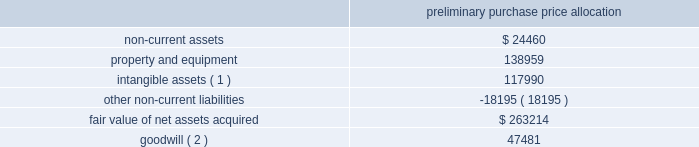American tower corporation and subsidiaries notes to consolidated financial statements the table summarizes the preliminary allocation of the aggregate purchase consideration paid and the amounts of assets acquired and liabilities assumed based upon their estimated fair value at the date of acquisition ( in thousands ) : preliminary purchase price allocation .
( 1 ) consists of customer-related intangibles of approximately $ 80.0 million and network location intangibles of approximately $ 38.0 million .
The customer-related intangibles and network location intangibles are being amortized on a straight-line basis over periods of up to 20 years .
( 2 ) the company expects that the goodwill recorded will be deductible for tax purposes .
The goodwill was allocated to the company 2019s international rental and management segment .
Ghana acquisition 2014on december 6 , 2010 , the company entered into a definitive agreement with mtn group limited ( 201cmtn group 201d ) to establish a joint venture in ghana .
The joint venture is controlled by a holding company of which a wholly owned subsidiary of the company ( the 201catc ghana subsidiary 201d ) holds a 51% ( 51 % ) interest and mobile telephone networks ( netherlands ) b.v. , a wholly owned subsidiary of mtn group ( the 201cmtn ghana subsidiary 201d ) holds a 49% ( 49 % ) interest .
The joint venture is managed and controlled by the company and owns a tower operations company in ghana .
Pursuant to the agreement , on may 6 , 2011 , august 11 , 2011 and december 23 , 2011 , the joint venture acquired 400 , 770 and 686 communications sites , respectively , from mtn group 2019s operating subsidiary in ghana for an aggregate purchase price of $ 515.6 million ( including contingent consideration of $ 2.3 million and value added tax of $ 65.6 million ) .
The aggregate purchase price was subsequently increased to $ 517.7 million ( including contingent consideration of $ 2.3 million and value added tax of $ 65.6 million ) after certain post-closing adjustments .
Under the terms of the purchase agreement , legal title to certain of the communications sites acquired on december 23 , 2011 will be transferred upon fulfillment of certain conditions by mtn group .
Prior to the fulfillment of these conditions , the company will operate and maintain control of these communications sites , and accordingly , reflect these sites in the allocation of purchase price and the consolidated operating results .
In december 2011 , the company signed an amendment to its agreement with mtn group , which requires the company to make additional payments upon the conversion of certain barter agreements with other wireless carriers to cash-paying master lease agreements .
The company currently estimates the fair value of remaining potential contingent consideration payments required to be made under the amended agreement to be between zero and $ 1.0 million and is estimated to be $ 0.9 million using a probability weighted average of the expected outcomes at december 31 , 2012 .
The company has previously made payments under this arrangement of $ 2.6 million .
During the year ended december 31 , 2012 , the company recorded an increase in fair value of $ 0.4 million as other operating expenses in the consolidated statements of operations. .
What is the annual amortization expense for the customer-related and network location intangibles , in millions? 
Computations: ((80.0 + 38.0) / 20)
Answer: 5.9. 